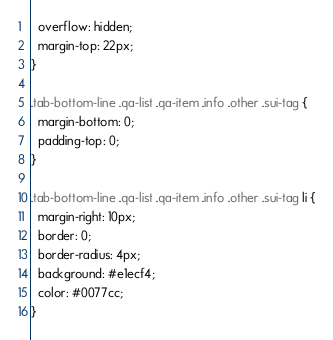<code> <loc_0><loc_0><loc_500><loc_500><_CSS_>  overflow: hidden;
  margin-top: 22px;
}

.tab-bottom-line .qa-list .qa-item .info .other .sui-tag {
  margin-bottom: 0;
  padding-top: 0;
}

.tab-bottom-line .qa-list .qa-item .info .other .sui-tag li {
  margin-right: 10px;
  border: 0;
  border-radius: 4px;
  background: #e1ecf4;
  color: #0077cc;
}
</code> 